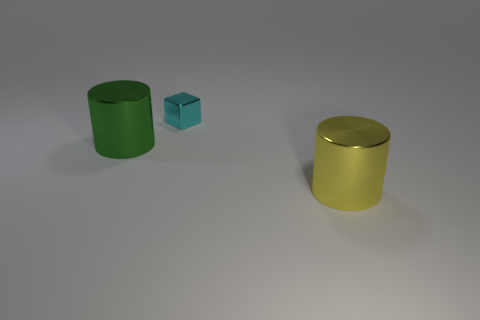Are there any other things that have the same size as the cyan metallic cube?
Provide a short and direct response. No. What number of things are big metal cylinders that are behind the large yellow metal cylinder or large cylinders that are in front of the large green metal thing?
Offer a very short reply. 2. Is there a yellow metallic cylinder of the same size as the green object?
Provide a short and direct response. Yes. What number of rubber things are either small cyan objects or tiny cylinders?
Provide a succinct answer. 0. The large green thing that is made of the same material as the cyan cube is what shape?
Your answer should be compact. Cylinder. How many big things are to the left of the tiny metal block and right of the green object?
Keep it short and to the point. 0. Are there any other things that are the same shape as the small thing?
Your response must be concise. No. How big is the shiny cylinder right of the large green metal cylinder?
Provide a succinct answer. Large. There is a cylinder that is on the left side of the big shiny thing that is right of the small cyan shiny cube; what is it made of?
Keep it short and to the point. Metal. There is a thing on the left side of the tiny cube; is it the same color as the metallic block?
Give a very brief answer. No. 